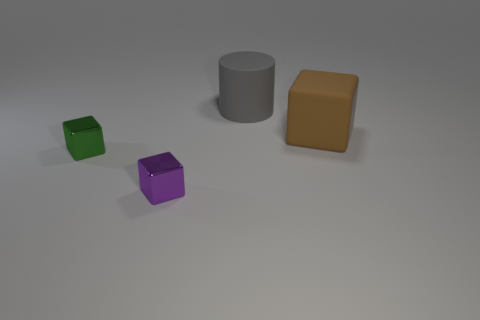Add 1 big brown matte objects. How many objects exist? 5 Subtract all cylinders. How many objects are left? 3 Add 2 matte cubes. How many matte cubes are left? 3 Add 3 small purple metallic blocks. How many small purple metallic blocks exist? 4 Subtract 1 gray cylinders. How many objects are left? 3 Subtract all blue objects. Subtract all green cubes. How many objects are left? 3 